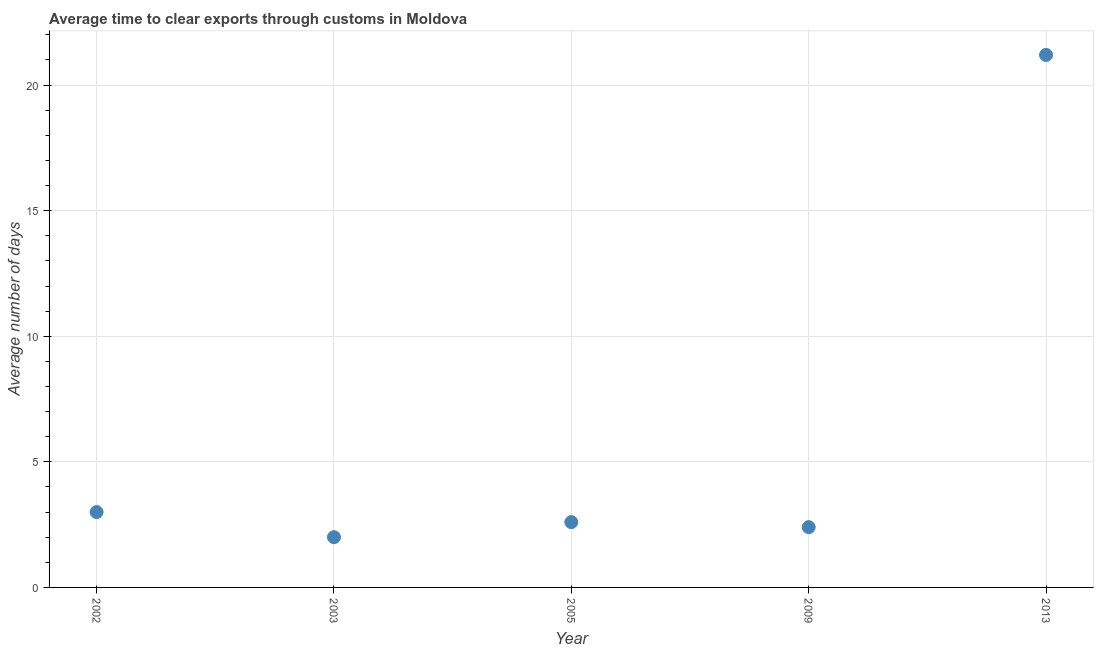What is the time to clear exports through customs in 2002?
Your response must be concise. 3. Across all years, what is the maximum time to clear exports through customs?
Your response must be concise. 21.2. In which year was the time to clear exports through customs minimum?
Make the answer very short. 2003. What is the sum of the time to clear exports through customs?
Offer a very short reply. 31.2. What is the difference between the time to clear exports through customs in 2003 and 2013?
Keep it short and to the point. -19.2. What is the average time to clear exports through customs per year?
Keep it short and to the point. 6.24. What is the median time to clear exports through customs?
Give a very brief answer. 2.6. In how many years, is the time to clear exports through customs greater than 2 days?
Provide a succinct answer. 4. Do a majority of the years between 2009 and 2002 (inclusive) have time to clear exports through customs greater than 4 days?
Offer a very short reply. Yes. Is the difference between the time to clear exports through customs in 2002 and 2003 greater than the difference between any two years?
Ensure brevity in your answer.  No. Is the sum of the time to clear exports through customs in 2002 and 2009 greater than the maximum time to clear exports through customs across all years?
Your answer should be compact. No. What is the difference between the highest and the lowest time to clear exports through customs?
Your answer should be very brief. 19.2. Does the time to clear exports through customs monotonically increase over the years?
Ensure brevity in your answer.  No. What is the difference between two consecutive major ticks on the Y-axis?
Your response must be concise. 5. Are the values on the major ticks of Y-axis written in scientific E-notation?
Offer a terse response. No. Does the graph contain any zero values?
Keep it short and to the point. No. Does the graph contain grids?
Keep it short and to the point. Yes. What is the title of the graph?
Your response must be concise. Average time to clear exports through customs in Moldova. What is the label or title of the X-axis?
Your response must be concise. Year. What is the label or title of the Y-axis?
Provide a short and direct response. Average number of days. What is the Average number of days in 2003?
Provide a succinct answer. 2. What is the Average number of days in 2005?
Your response must be concise. 2.6. What is the Average number of days in 2013?
Your answer should be compact. 21.2. What is the difference between the Average number of days in 2002 and 2003?
Your response must be concise. 1. What is the difference between the Average number of days in 2002 and 2009?
Offer a terse response. 0.6. What is the difference between the Average number of days in 2002 and 2013?
Keep it short and to the point. -18.2. What is the difference between the Average number of days in 2003 and 2009?
Make the answer very short. -0.4. What is the difference between the Average number of days in 2003 and 2013?
Provide a succinct answer. -19.2. What is the difference between the Average number of days in 2005 and 2013?
Your answer should be very brief. -18.6. What is the difference between the Average number of days in 2009 and 2013?
Your answer should be very brief. -18.8. What is the ratio of the Average number of days in 2002 to that in 2003?
Provide a succinct answer. 1.5. What is the ratio of the Average number of days in 2002 to that in 2005?
Keep it short and to the point. 1.15. What is the ratio of the Average number of days in 2002 to that in 2009?
Offer a very short reply. 1.25. What is the ratio of the Average number of days in 2002 to that in 2013?
Provide a succinct answer. 0.14. What is the ratio of the Average number of days in 2003 to that in 2005?
Keep it short and to the point. 0.77. What is the ratio of the Average number of days in 2003 to that in 2009?
Offer a terse response. 0.83. What is the ratio of the Average number of days in 2003 to that in 2013?
Provide a succinct answer. 0.09. What is the ratio of the Average number of days in 2005 to that in 2009?
Make the answer very short. 1.08. What is the ratio of the Average number of days in 2005 to that in 2013?
Make the answer very short. 0.12. What is the ratio of the Average number of days in 2009 to that in 2013?
Keep it short and to the point. 0.11. 